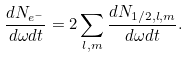<formula> <loc_0><loc_0><loc_500><loc_500>\frac { d N _ { e ^ { - } } } { d \omega d t } = 2 \sum _ { l , m } \frac { d N _ { 1 / 2 , l , m } } { d \omega d t } .</formula> 